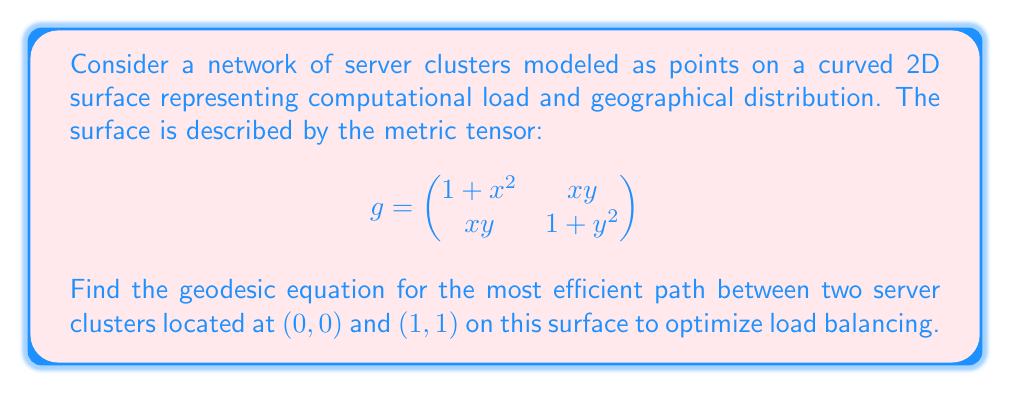Teach me how to tackle this problem. To find the geodesic equation, we'll follow these steps:

1) First, we need to calculate the Christoffel symbols using the metric tensor:

   $$\Gamma^k_{ij} = \frac{1}{2}g^{kl}(\partial_i g_{jl} + \partial_j g_{il} - \partial_l g_{ij})$$

2) The inverse metric tensor $g^{-1}$ is:

   $$g^{-1} = \frac{1}{(1+x^2)(1+y^2)-x^2y^2}\begin{pmatrix}
   1+y^2 & -xy \\
   -xy & 1+x^2
   \end{pmatrix}$$

3) Calculating the non-zero Christoffel symbols:

   $$\Gamma^1_{11} = \frac{x(1+y^2)}{(1+x^2)(1+y^2)-x^2y^2}$$
   $$\Gamma^1_{12} = \Gamma^1_{21} = \frac{y(1+y^2)}{(1+x^2)(1+y^2)-x^2y^2}$$
   $$\Gamma^2_{11} = -\frac{xy}{(1+x^2)(1+y^2)-x^2y^2}$$
   $$\Gamma^2_{12} = \Gamma^2_{21} = \frac{x(1+x^2)}{(1+x^2)(1+y^2)-x^2y^2}$$
   $$\Gamma^1_{22} = -\frac{xy}{(1+x^2)(1+y^2)-x^2y^2}$$
   $$\Gamma^2_{22} = \frac{y(1+x^2)}{(1+x^2)(1+y^2)-x^2y^2}$$

4) The geodesic equations are:

   $$\frac{d^2x^i}{dt^2} + \Gamma^i_{jk}\frac{dx^j}{dt}\frac{dx^k}{dt} = 0$$

5) Substituting the Christoffel symbols, we get two coupled differential equations:

   $$\frac{d^2x}{dt^2} + \frac{x(1+y^2)}{(1+x^2)(1+y^2)-x^2y^2}\left(\frac{dx}{dt}\right)^2 + \frac{2y(1+y^2)}{(1+x^2)(1+y^2)-x^2y^2}\frac{dx}{dt}\frac{dy}{dt} - \frac{xy}{(1+x^2)(1+y^2)-x^2y^2}\left(\frac{dy}{dt}\right)^2 = 0$$

   $$\frac{d^2y}{dt^2} - \frac{xy}{(1+x^2)(1+y^2)-x^2y^2}\left(\frac{dx}{dt}\right)^2 + \frac{2x(1+x^2)}{(1+x^2)(1+y^2)-x^2y^2}\frac{dx}{dt}\frac{dy}{dt} + \frac{y(1+x^2)}{(1+x^2)(1+y^2)-x^2y^2}\left(\frac{dy}{dt}\right)^2 = 0$$

6) These equations describe the geodesic path between the server clusters, with boundary conditions $x(0)=0$, $y(0)=0$, $x(1)=1$, $y(1)=1$.
Answer: $$\begin{cases}
\frac{d^2x}{dt^2} + \frac{x(1+y^2)}{(1+x^2)(1+y^2)-x^2y^2}\left(\frac{dx}{dt}\right)^2 + \frac{2y(1+y^2)}{(1+x^2)(1+y^2)-x^2y^2}\frac{dx}{dt}\frac{dy}{dt} - \frac{xy}{(1+x^2)(1+y^2)-x^2y^2}\left(\frac{dy}{dt}\right)^2 = 0 \\
\frac{d^2y}{dt^2} - \frac{xy}{(1+x^2)(1+y^2)-x^2y^2}\left(\frac{dx}{dt}\right)^2 + \frac{2x(1+x^2)}{(1+x^2)(1+y^2)-x^2y^2}\frac{dx}{dt}\frac{dy}{dt} + \frac{y(1+x^2)}{(1+x^2)(1+y^2)-x^2y^2}\left(\frac{dy}{dt}\right)^2 = 0
\end{cases}$$ 